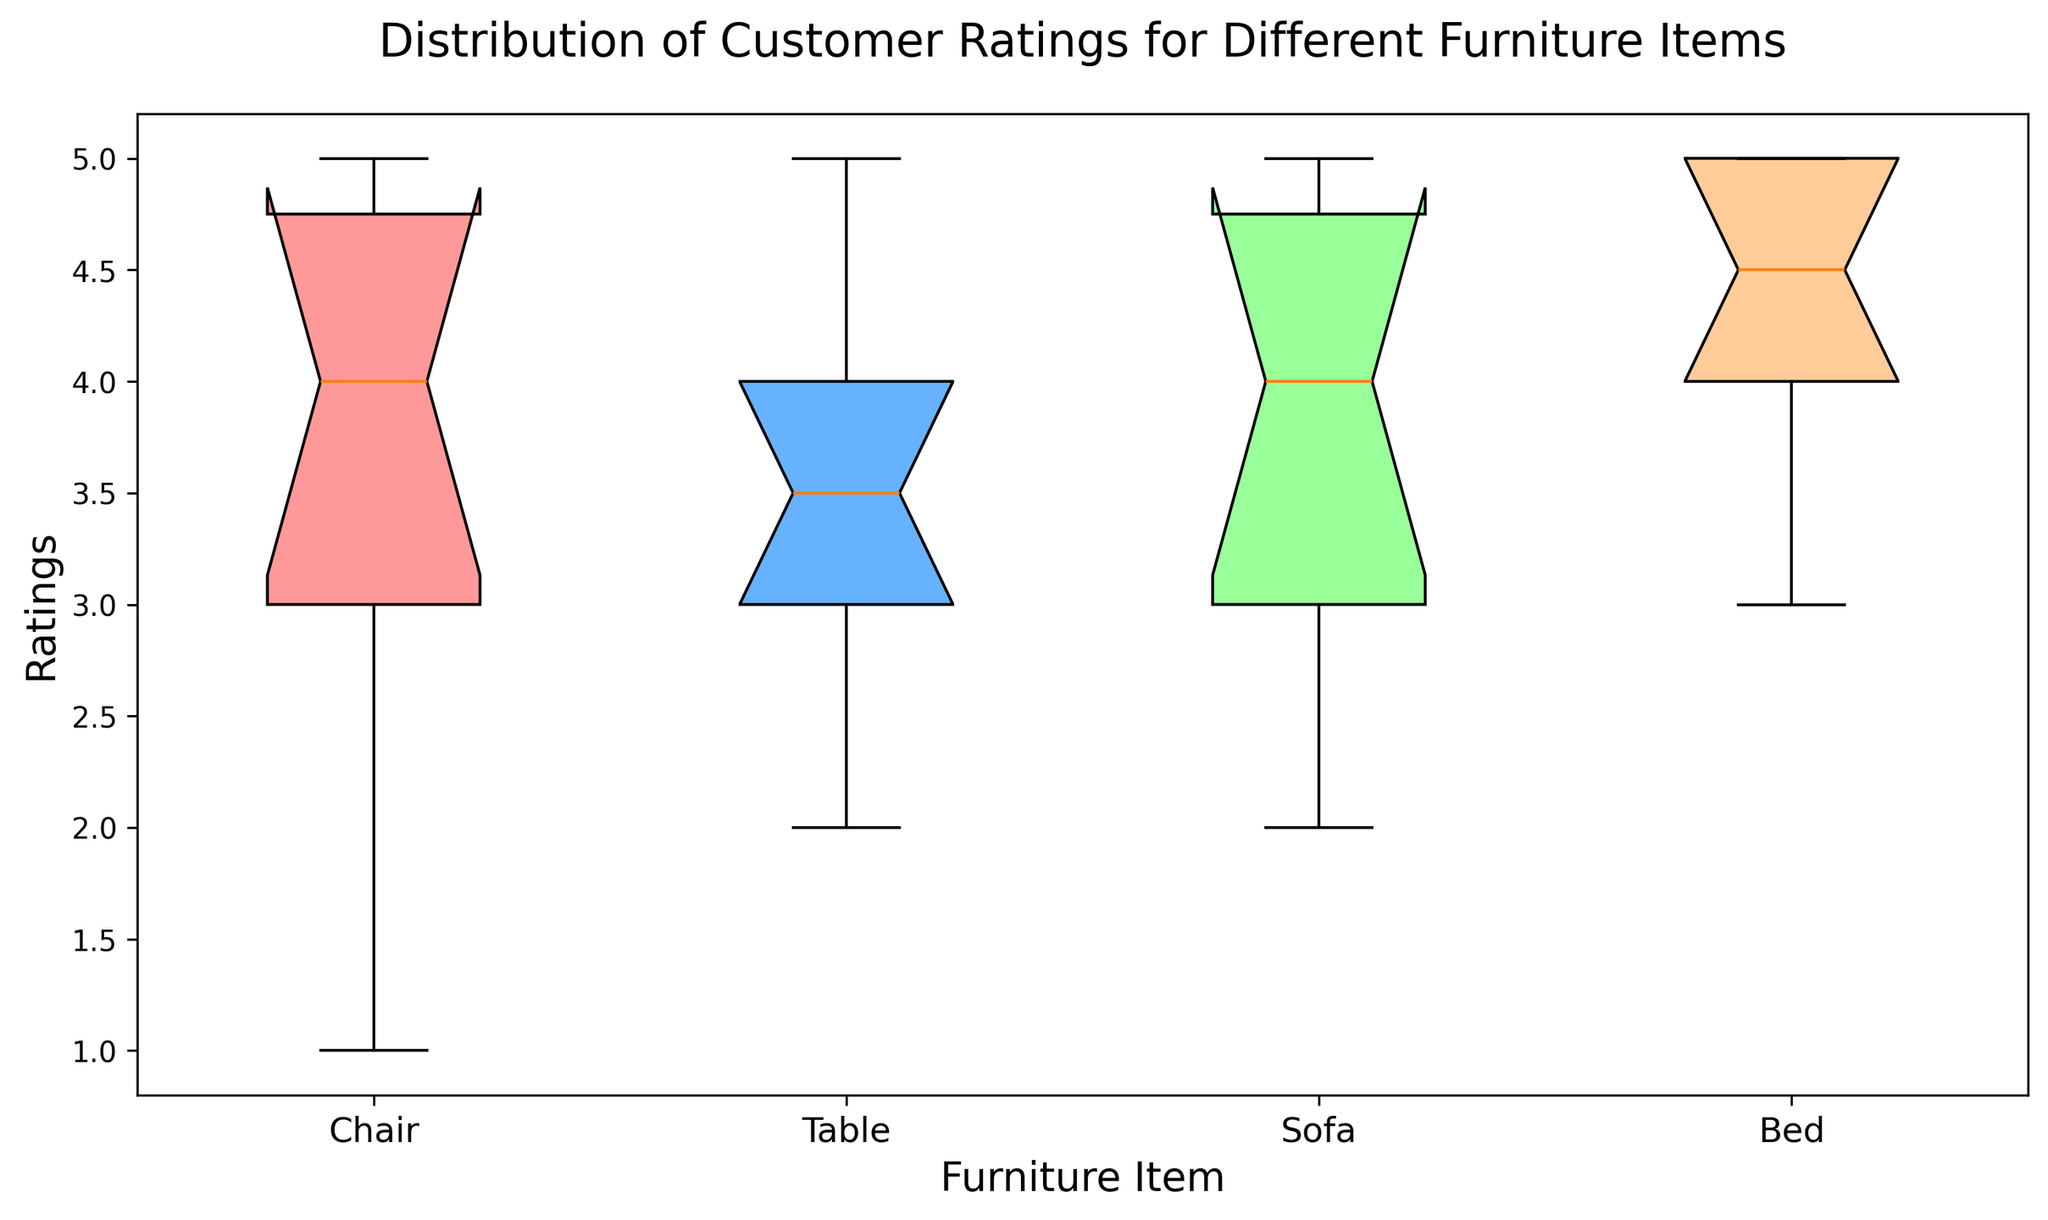Which item has the most consistent ratings (smallest interquartile range)? Check the box plot with the smallest height of the box (distance between the upper and lower quartiles).
Answer: Bed Are there any outliers in the Chair ratings? An outlier is represented by a dot outside the whiskers on the box plot. The Chair has a dot at rating 1, which is an outlier.
Answer: Yes Among Chair and Table, which item has a wider range of ratings? Compare the length of the whiskers for Chair and Table. The Chair has longer whiskers, indicating a wider range.
Answer: Chair What is the interquartile range (IQR) of the Sofa ratings? The IQR is the height of the box, which is the difference between the upper quartile (75th percentile) and lower quartile (25th percentile) for the Sofa. Use the box plot to find these values and subtract. Lower quartile is around 3, and upper quartile is around 5, so IQR = 5 - 3.
Answer: 2 Which item has more high ratings (closer to 5), Bed or Table? Observe the distribution of the ratings for Bed and Table. Beds have a higher concentration of ratings closer to 5.
Answer: Bed What is the lowest rating for the Table? Observe the bottom whisker or any dots below the box for Table; the lowest point is the lowest rating.
Answer: 2 Does the Bed have any median rating higher than the other items? Compare the center lines (medians) of all items. The median rating of Bed is as high as Sofa but not higher.
Answer: No 